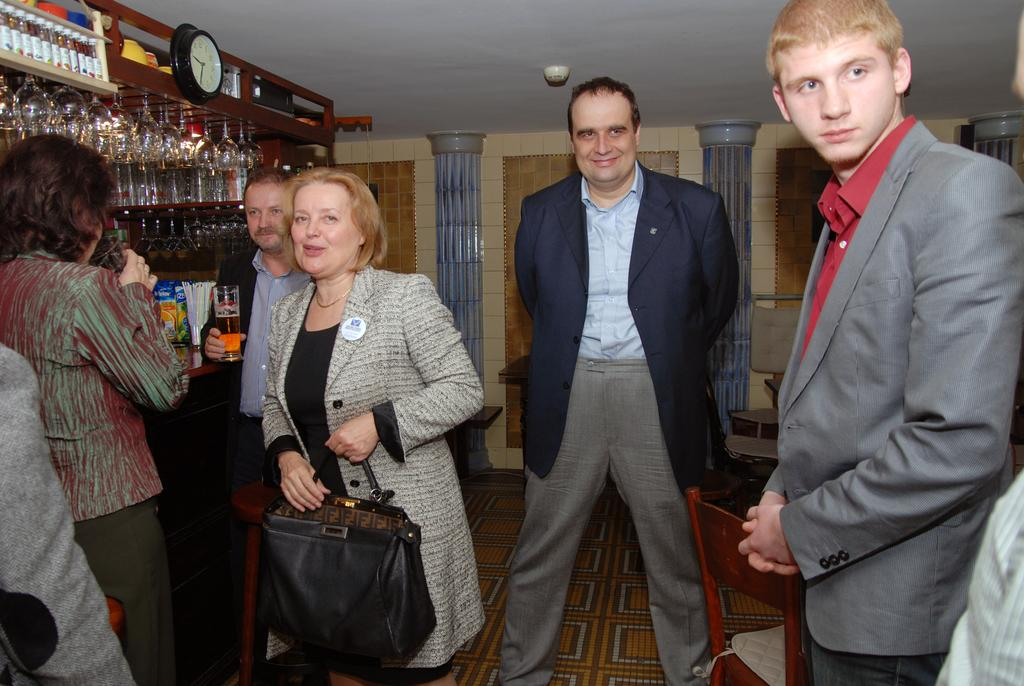How many people are in the image? There are people in the image, but the exact number is not specified. What type of furniture is present in the image? There are chairs in the image. What part of the room can be seen in the image? The floor is visible in the image. What type of containers are in the image? There are bottles and glasses in the image. What time-keeping device is in the image? There is a clock in the image. What type of surface is present in the image? There is a wall in the image. Can you describe any other objects in the image? Other objects are present in the image, but their specific details are not provided. What type of stone is used to build the park in the image? There is no park present in the image, and therefore no stone can be observed. What arithmetic problem is being solved by the people in the image? There is no indication in the image that the people are solving an arithmetic problem. 